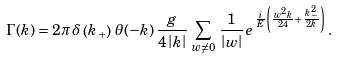<formula> <loc_0><loc_0><loc_500><loc_500>\Gamma ( k ) = 2 \pi \, \delta \left ( k _ { + } \right ) \, \theta ( - k ) \, \frac { g } { 4 \left | k \right | } \, \sum _ { w \neq 0 } \, \frac { 1 } { \left | w \right | } \, e ^ { \, \frac { i } { E } \left ( \frac { w ^ { 2 } k } { 2 4 } + \frac { k _ { - } ^ { \, 2 } } { 2 k } \right ) } \, .</formula> 